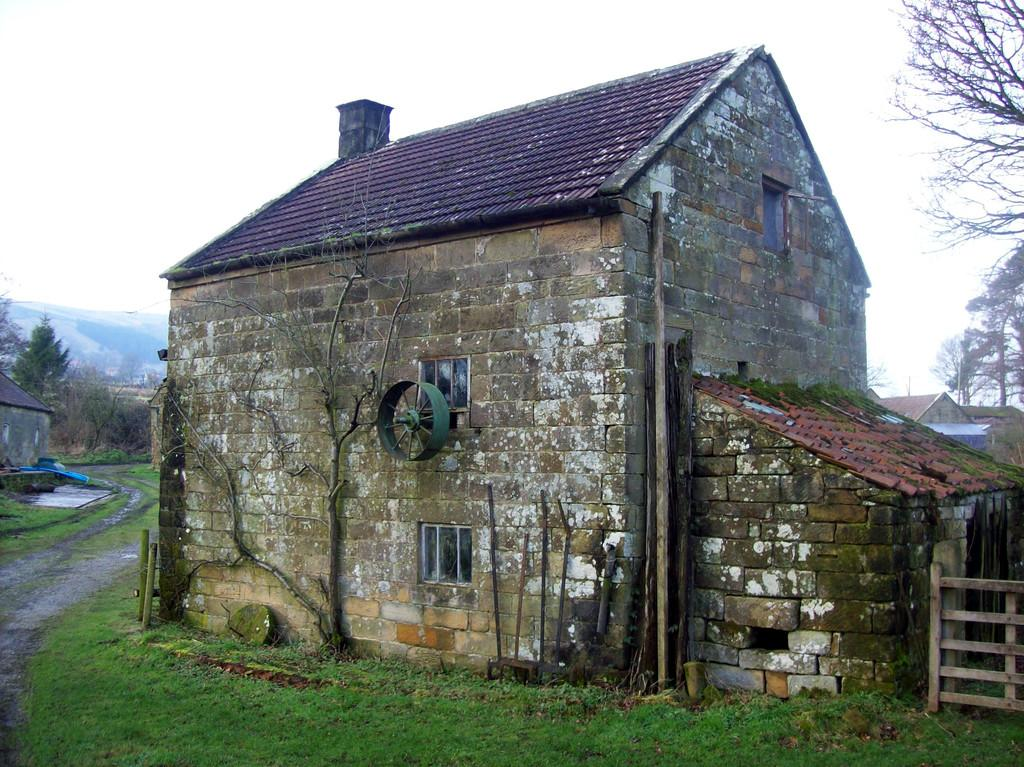What type of structures can be seen in the image? There are houses in the image. What type of vegetation is present in the image? There is green grass and trees in the image. What pathway is visible in the image? There is a walkway in the image. What can be seen in the sky in the image? Clouds are visible in the sky. Where are the friends sitting with the pot in the image? There is no pot or friends present in the image. 